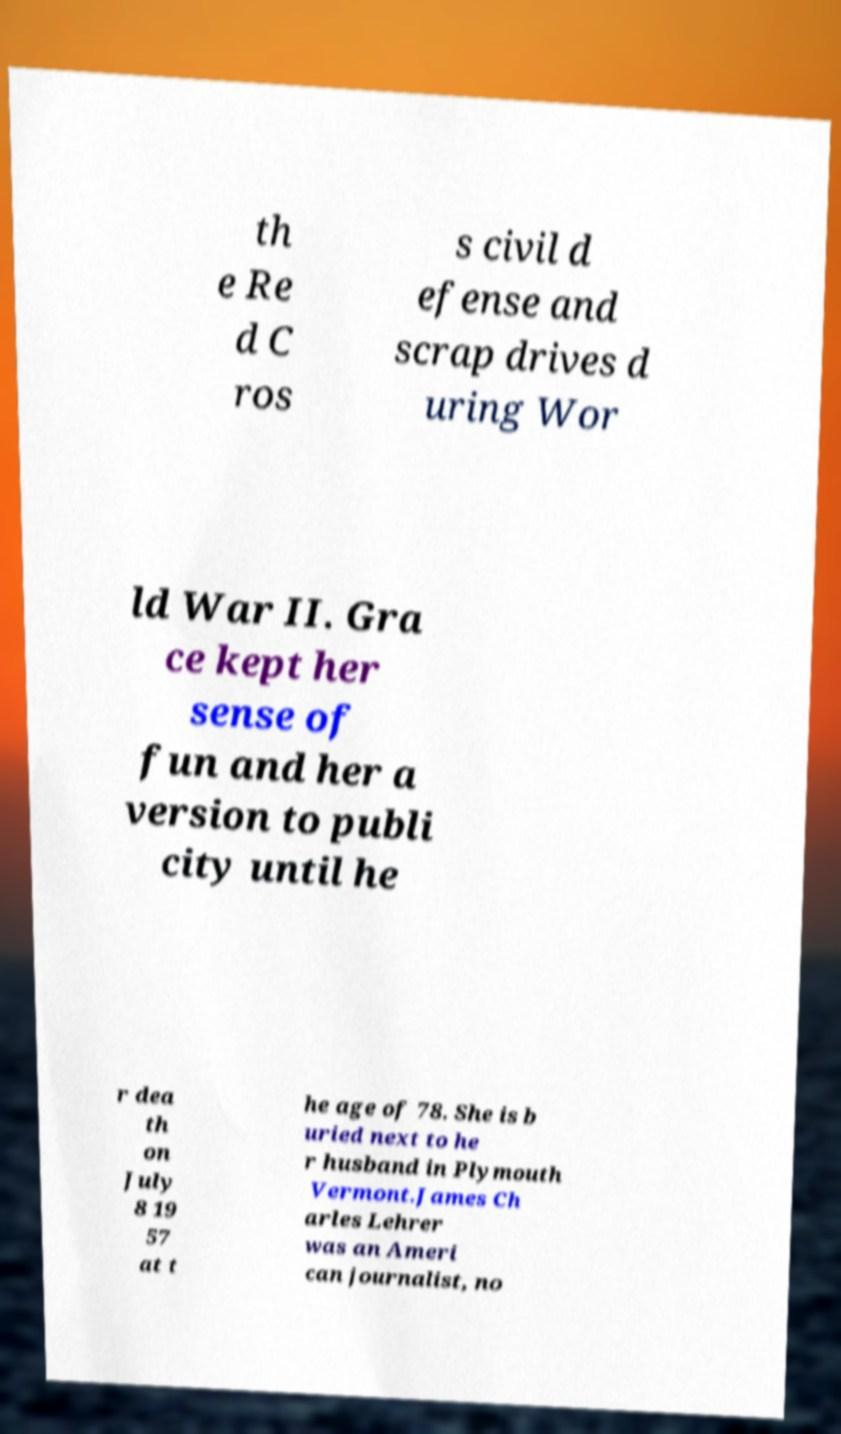Can you accurately transcribe the text from the provided image for me? th e Re d C ros s civil d efense and scrap drives d uring Wor ld War II. Gra ce kept her sense of fun and her a version to publi city until he r dea th on July 8 19 57 at t he age of 78. She is b uried next to he r husband in Plymouth Vermont.James Ch arles Lehrer was an Ameri can journalist, no 